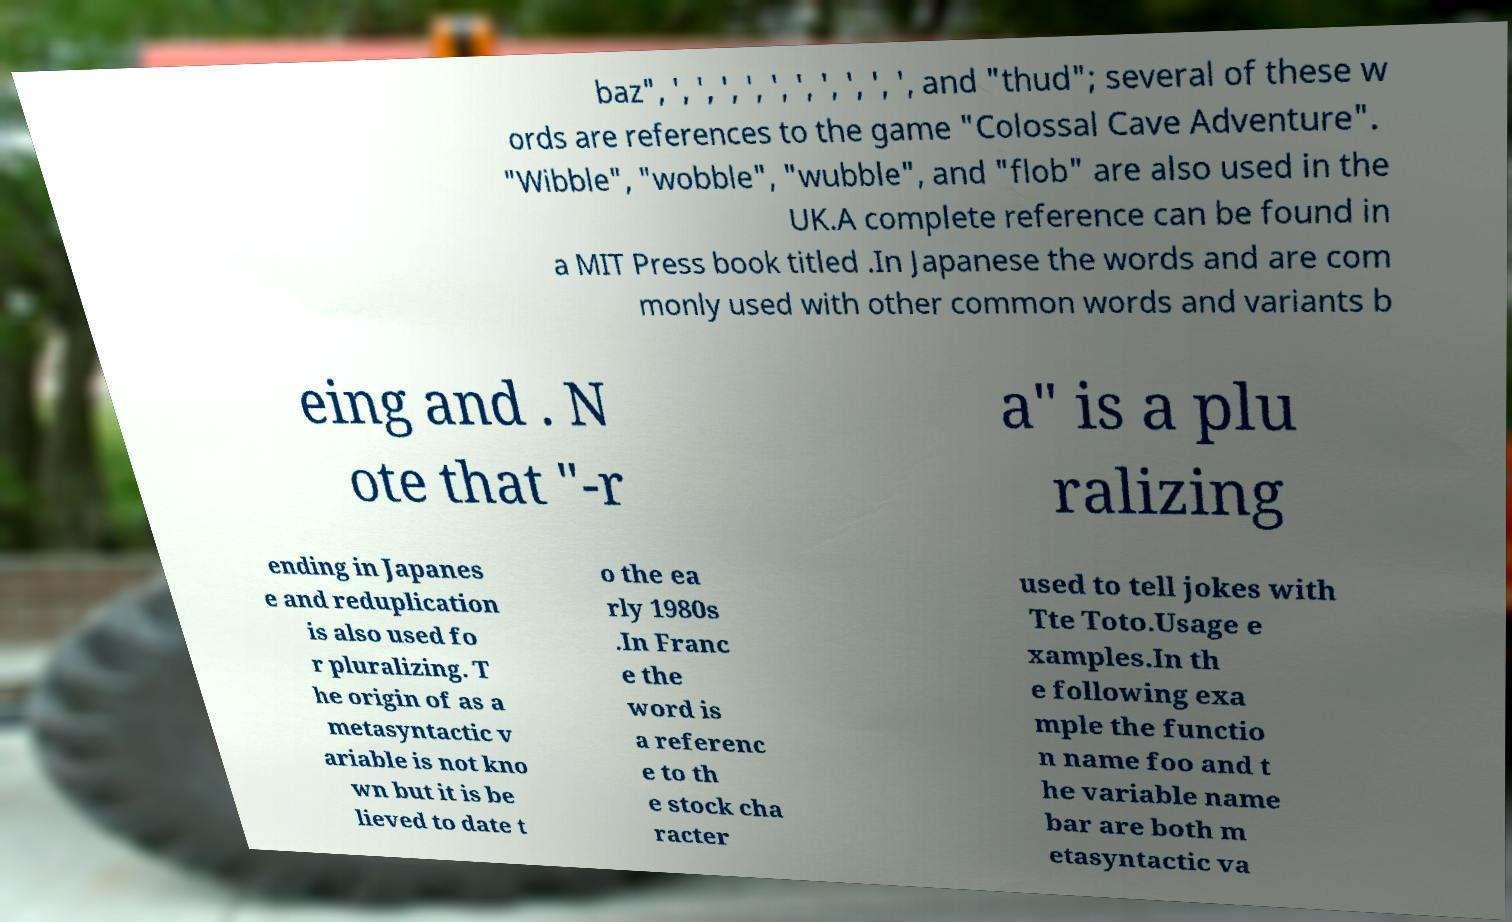Please read and relay the text visible in this image. What does it say? baz", ', ', ', ', ', ', ', ', ', ', and "thud"; several of these w ords are references to the game "Colossal Cave Adventure". "Wibble", "wobble", "wubble", and "flob" are also used in the UK.A complete reference can be found in a MIT Press book titled .In Japanese the words and are com monly used with other common words and variants b eing and . N ote that "-r a" is a plu ralizing ending in Japanes e and reduplication is also used fo r pluralizing. T he origin of as a metasyntactic v ariable is not kno wn but it is be lieved to date t o the ea rly 1980s .In Franc e the word is a referenc e to th e stock cha racter used to tell jokes with Tte Toto.Usage e xamples.In th e following exa mple the functio n name foo and t he variable name bar are both m etasyntactic va 